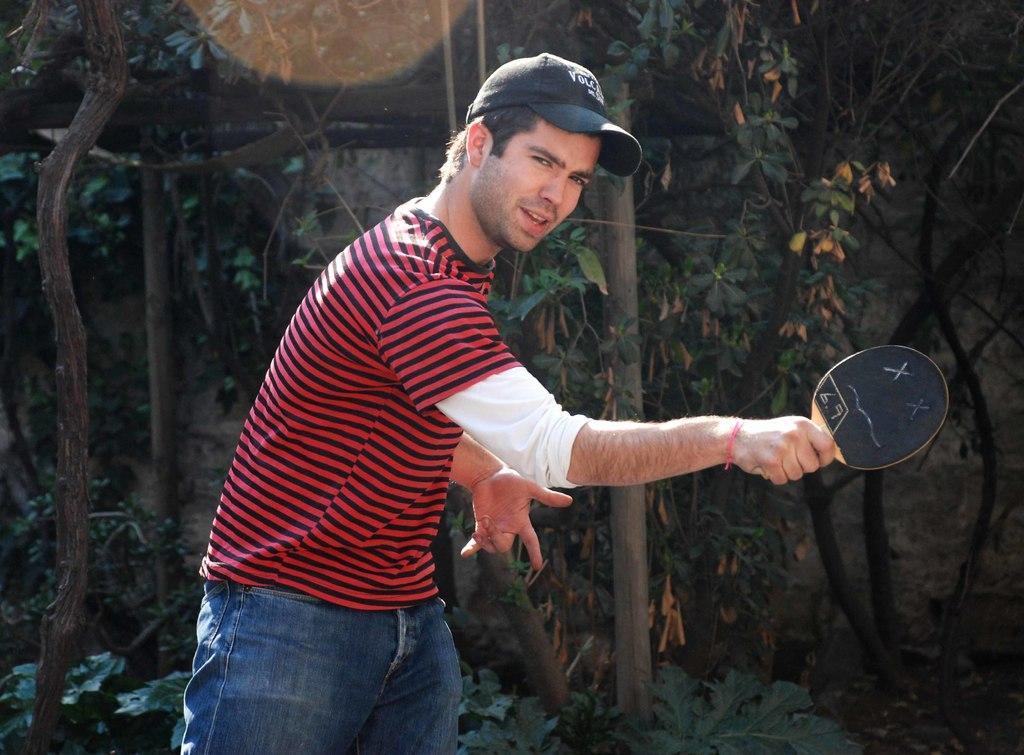How would you summarize this image in a sentence or two? Here in this picture we can see a person standing with a small tennis racket in his hand and we can see he is wearing a cap on him and behind him we can see plants and trees present over there. 